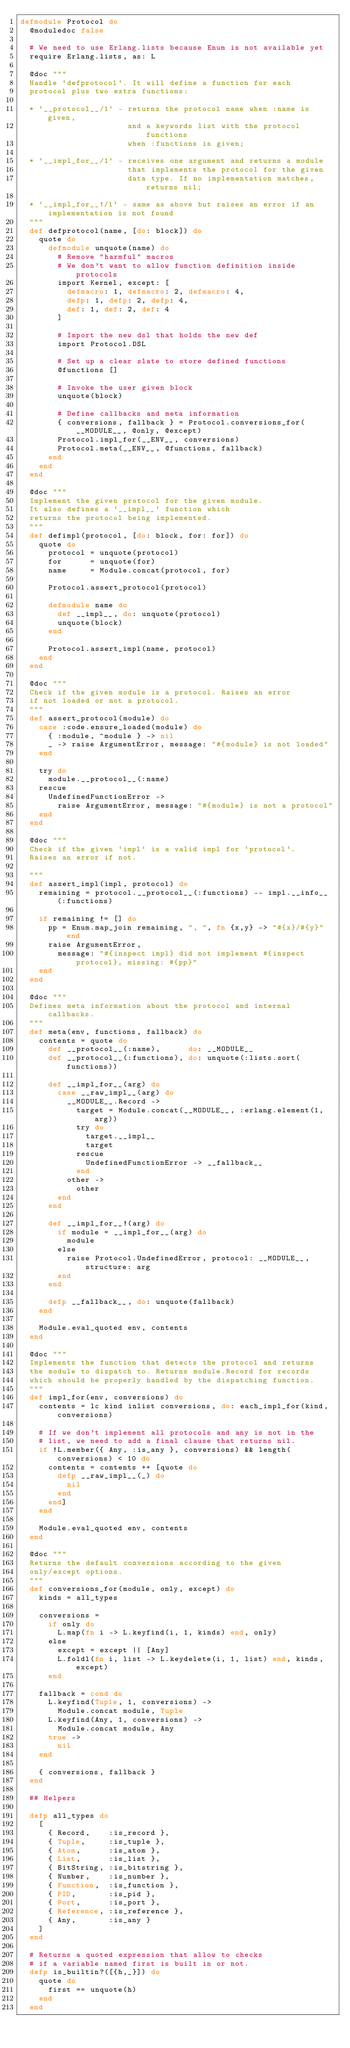Convert code to text. <code><loc_0><loc_0><loc_500><loc_500><_Elixir_>defmodule Protocol do
  @moduledoc false

  # We need to use Erlang.lists because Enum is not available yet
  require Erlang.lists, as: L

  @doc """
  Handle `defprotocol`. It will define a function for each
  protocol plus two extra functions:

  * `__protocol__/1` - returns the protocol name when :name is given,
                       and a keywords list with the protocol functions
                       when :functions is given;

  * `__impl_for__/1` - receives one argument and returns a module
                       that implements the protocol for the given
                       data type. If no implementation matches, returns nil;

  * `__impl_for__!/1` - same as above but raises an error if an implementation is not found
  """
  def defprotocol(name, [do: block]) do
    quote do
      defmodule unquote(name) do
        # Remove "harmful" macros
        # We don't want to allow function definition inside protocols
        import Kernel, except: [
          defmacro: 1, defmacro: 2, defmacro: 4,
          defp: 1, defp: 2, defp: 4,
          def: 1, def: 2, def: 4
        ]

        # Import the new dsl that holds the new def
        import Protocol.DSL

        # Set up a clear slate to store defined functions
        @functions []

        # Invoke the user given block
        unquote(block)

        # Define callbacks and meta information
        { conversions, fallback } = Protocol.conversions_for(__MODULE__, @only, @except)
        Protocol.impl_for(__ENV__, conversions)
        Protocol.meta(__ENV__, @functions, fallback)
      end
    end
  end

  @doc """
  Implement the given protocol for the given module.
  It also defines a `__impl__` function which
  returns the protocol being implemented.
  """
  def defimpl(protocol, [do: block, for: for]) do
    quote do
      protocol = unquote(protocol)
      for      = unquote(for)
      name     = Module.concat(protocol, for)

      Protocol.assert_protocol(protocol)

      defmodule name do
        def __impl__, do: unquote(protocol)
        unquote(block)
      end

      Protocol.assert_impl(name, protocol)
    end
  end

  @doc """
  Check if the given module is a protocol. Raises an error
  if not loaded or not a protocol.
  """
  def assert_protocol(module) do
    case :code.ensure_loaded(module) do
      { :module, ^module } -> nil
      _ -> raise ArgumentError, message: "#{module} is not loaded"
    end

    try do
      module.__protocol__(:name)
    rescue
      UndefinedFunctionError ->
        raise ArgumentError, message: "#{module} is not a protocol"
    end
  end

  @doc """
  Check if the given `impl` is a valid impl for `protocol`.
  Raises an error if not.

  """
  def assert_impl(impl, protocol) do
    remaining = protocol.__protocol__(:functions) -- impl.__info__(:functions)

    if remaining != [] do
      pp = Enum.map_join remaining, ", ", fn {x,y} -> "#{x}/#{y}" end
      raise ArgumentError,
        message: "#{inspect impl} did not implement #{inspect protocol}, missing: #{pp}"
    end
  end

  @doc """
  Defines meta information about the protocol and internal callbacks.
  """
  def meta(env, functions, fallback) do
    contents = quote do
      def __protocol__(:name),      do: __MODULE__
      def __protocol__(:functions), do: unquote(:lists.sort(functions))

      def __impl_for__(arg) do
        case __raw_impl__(arg) do
          __MODULE__.Record ->
            target = Module.concat(__MODULE__, :erlang.element(1, arg))
            try do
              target.__impl__
              target
            rescue
              UndefinedFunctionError -> __fallback__
            end
          other ->
            other
        end
      end

      def __impl_for__!(arg) do
        if module = __impl_for__(arg) do
          module
        else
          raise Protocol.UndefinedError, protocol: __MODULE__, structure: arg
        end
      end

      defp __fallback__, do: unquote(fallback)
    end

    Module.eval_quoted env, contents
  end

  @doc """
  Implements the function that detects the protocol and returns
  the module to dispatch to. Returns module.Record for records
  which should be properly handled by the dispatching function.
  """
  def impl_for(env, conversions) do
    contents = lc kind inlist conversions, do: each_impl_for(kind, conversions)

    # If we don't implement all protocols and any is not in the
    # list, we need to add a final clause that returns nil.
    if !L.member({ Any, :is_any }, conversions) && length(conversions) < 10 do
      contents = contents ++ [quote do
        defp __raw_impl__(_) do
          nil
        end
      end]
    end

    Module.eval_quoted env, contents
  end

  @doc """
  Returns the default conversions according to the given
  only/except options.
  """
  def conversions_for(module, only, except) do
    kinds = all_types

    conversions =
      if only do
        L.map(fn i -> L.keyfind(i, 1, kinds) end, only)
      else
        except = except || [Any]
        L.foldl(fn i, list -> L.keydelete(i, 1, list) end, kinds, except)
      end

    fallback = cond do
      L.keyfind(Tuple, 1, conversions) ->
        Module.concat module, Tuple
      L.keyfind(Any, 1, conversions) ->
        Module.concat module, Any
      true ->
        nil
    end

    { conversions, fallback }
  end

  ## Helpers

  defp all_types do
    [
      { Record,    :is_record },
      { Tuple,     :is_tuple },
      { Atom,      :is_atom },
      { List,      :is_list },
      { BitString, :is_bitstring },
      { Number,    :is_number },
      { Function,  :is_function },
      { PID,       :is_pid },
      { Port,      :is_port },
      { Reference, :is_reference },
      { Any,       :is_any }
    ]
  end

  # Returns a quoted expression that allow to checks
  # if a variable named first is built in or not.
  defp is_builtin?([{h,_}]) do
    quote do
      first == unquote(h)
    end
  end
</code> 